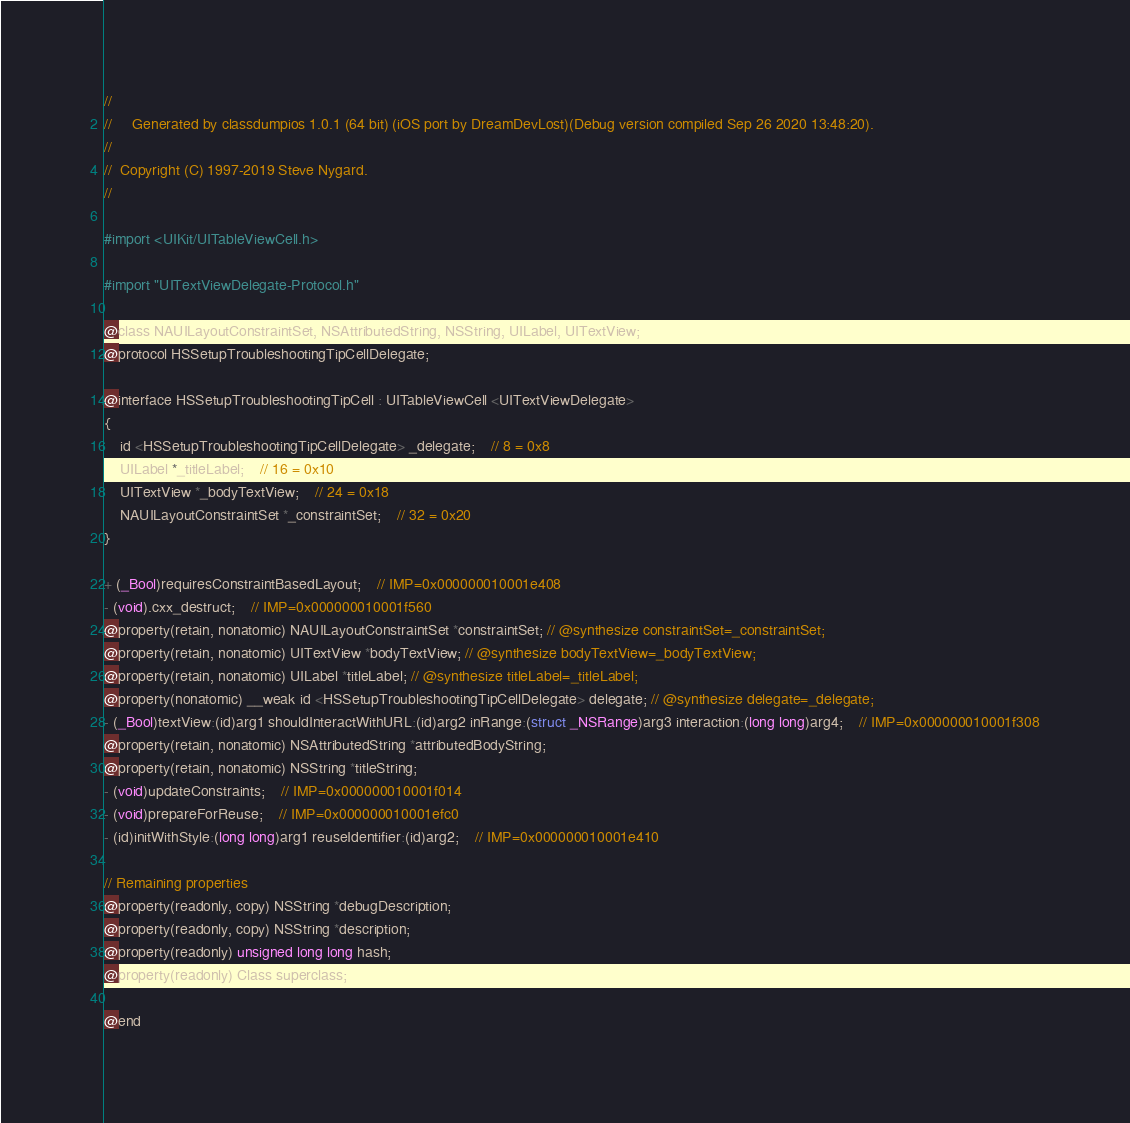Convert code to text. <code><loc_0><loc_0><loc_500><loc_500><_C_>//
//     Generated by classdumpios 1.0.1 (64 bit) (iOS port by DreamDevLost)(Debug version compiled Sep 26 2020 13:48:20).
//
//  Copyright (C) 1997-2019 Steve Nygard.
//

#import <UIKit/UITableViewCell.h>

#import "UITextViewDelegate-Protocol.h"

@class NAUILayoutConstraintSet, NSAttributedString, NSString, UILabel, UITextView;
@protocol HSSetupTroubleshootingTipCellDelegate;

@interface HSSetupTroubleshootingTipCell : UITableViewCell <UITextViewDelegate>
{
    id <HSSetupTroubleshootingTipCellDelegate> _delegate;	// 8 = 0x8
    UILabel *_titleLabel;	// 16 = 0x10
    UITextView *_bodyTextView;	// 24 = 0x18
    NAUILayoutConstraintSet *_constraintSet;	// 32 = 0x20
}

+ (_Bool)requiresConstraintBasedLayout;	// IMP=0x000000010001e408
- (void).cxx_destruct;	// IMP=0x000000010001f560
@property(retain, nonatomic) NAUILayoutConstraintSet *constraintSet; // @synthesize constraintSet=_constraintSet;
@property(retain, nonatomic) UITextView *bodyTextView; // @synthesize bodyTextView=_bodyTextView;
@property(retain, nonatomic) UILabel *titleLabel; // @synthesize titleLabel=_titleLabel;
@property(nonatomic) __weak id <HSSetupTroubleshootingTipCellDelegate> delegate; // @synthesize delegate=_delegate;
- (_Bool)textView:(id)arg1 shouldInteractWithURL:(id)arg2 inRange:(struct _NSRange)arg3 interaction:(long long)arg4;	// IMP=0x000000010001f308
@property(retain, nonatomic) NSAttributedString *attributedBodyString;
@property(retain, nonatomic) NSString *titleString;
- (void)updateConstraints;	// IMP=0x000000010001f014
- (void)prepareForReuse;	// IMP=0x000000010001efc0
- (id)initWithStyle:(long long)arg1 reuseIdentifier:(id)arg2;	// IMP=0x000000010001e410

// Remaining properties
@property(readonly, copy) NSString *debugDescription;
@property(readonly, copy) NSString *description;
@property(readonly) unsigned long long hash;
@property(readonly) Class superclass;

@end

</code> 